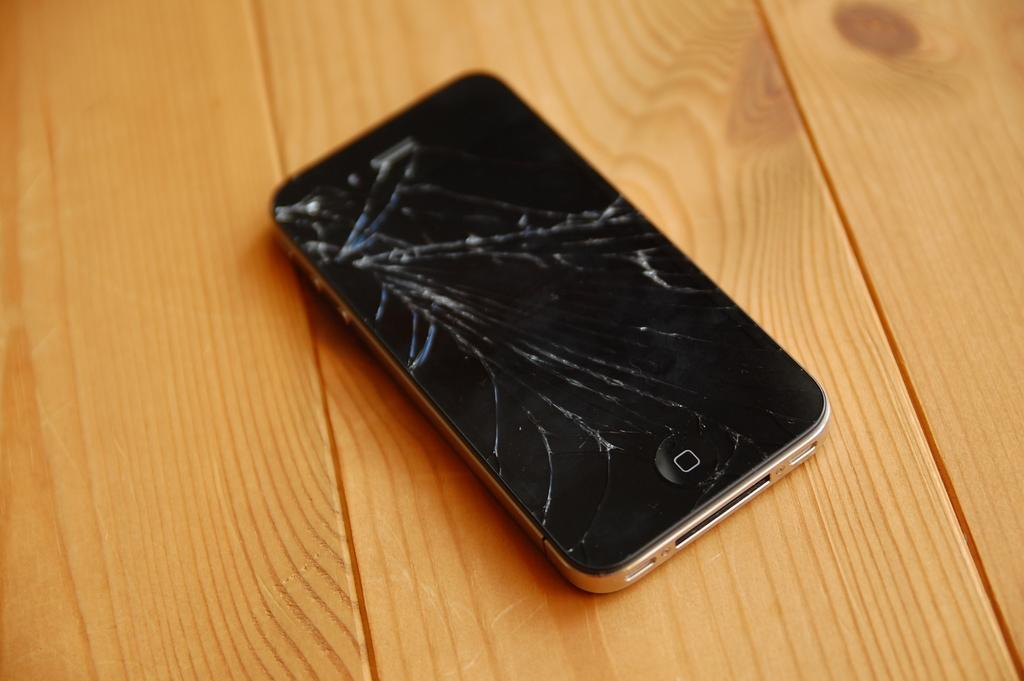<image>
Render a clear and concise summary of the photo. A square looking letter O is shown on the bottom of a cracked cellphone. 